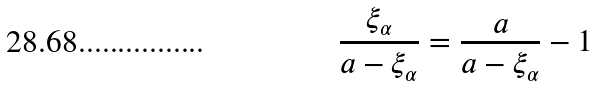<formula> <loc_0><loc_0><loc_500><loc_500>\frac { \xi _ { \alpha } } { a - \xi _ { \alpha } } = \frac { a } { a - \xi _ { \alpha } } - 1</formula> 